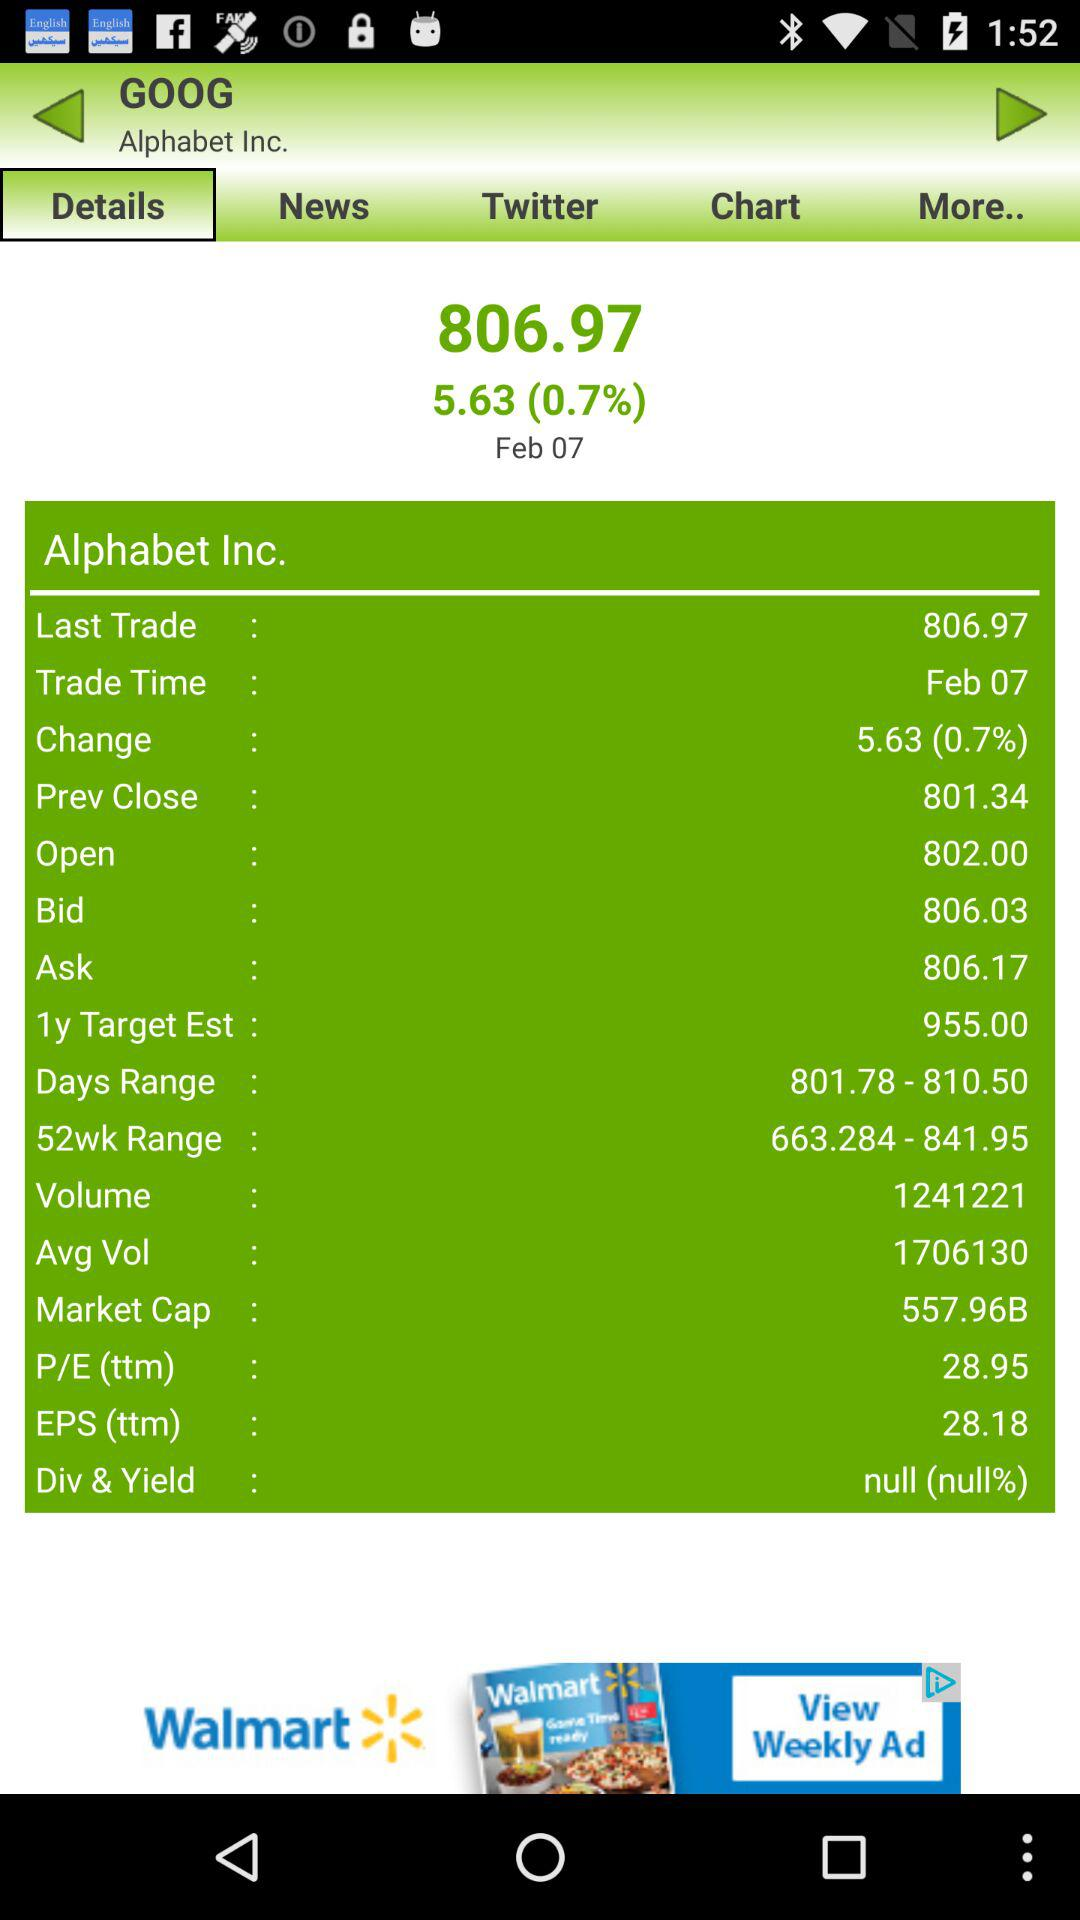What is the percentage change in "Alphabet Inc." stock? The percentage change is 0.7. 